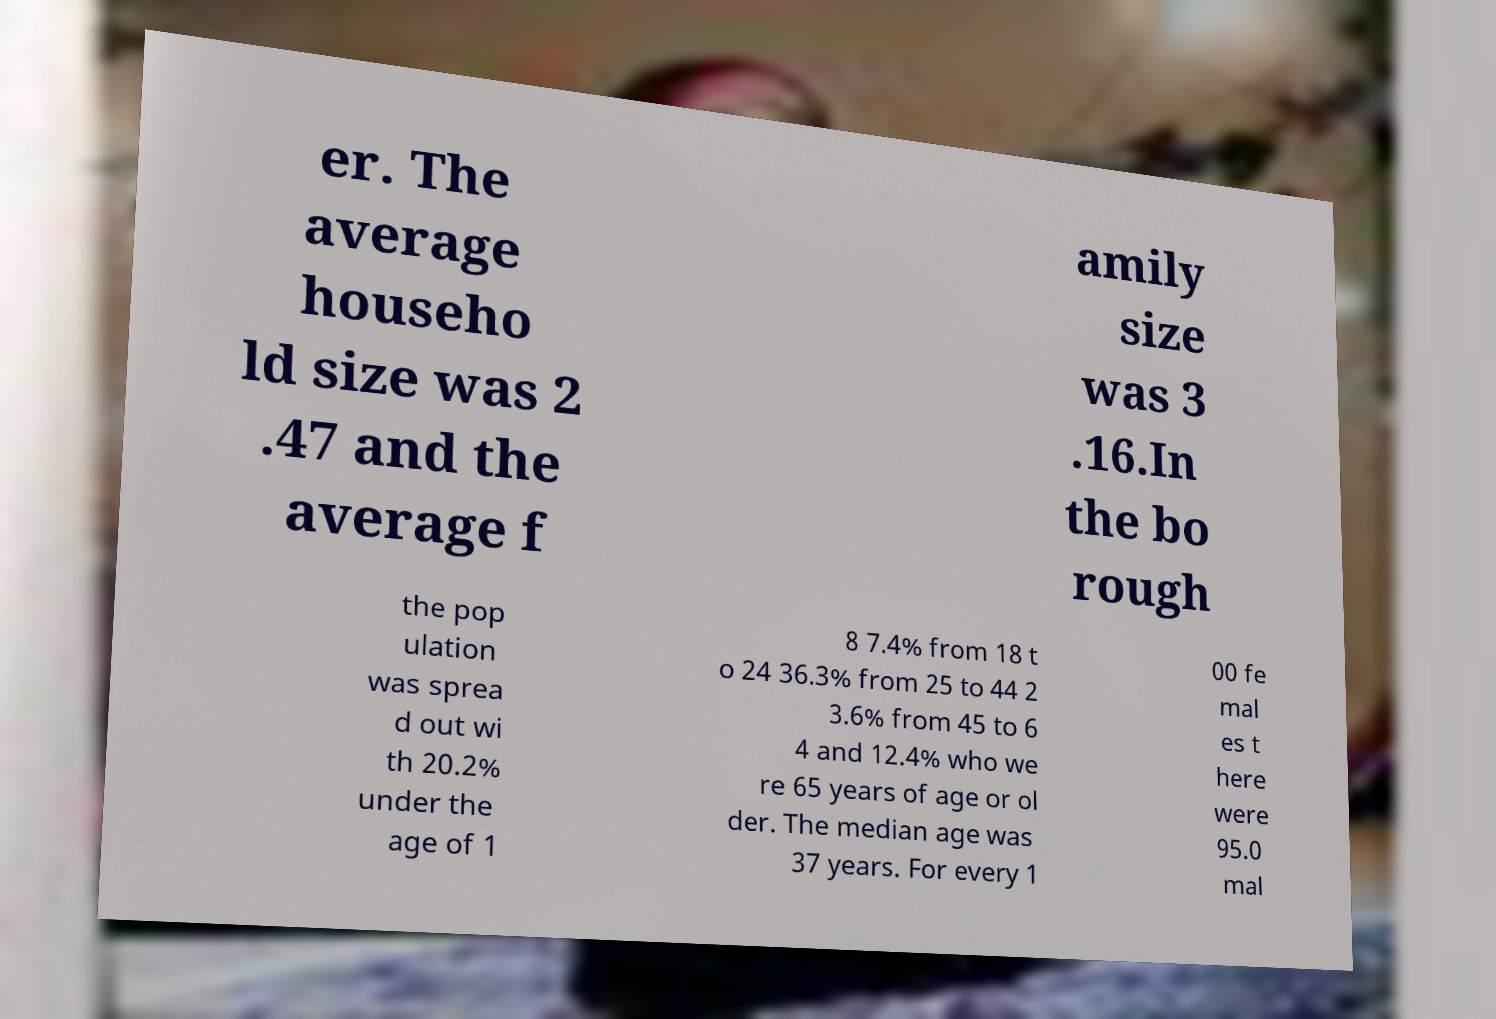For documentation purposes, I need the text within this image transcribed. Could you provide that? er. The average househo ld size was 2 .47 and the average f amily size was 3 .16.In the bo rough the pop ulation was sprea d out wi th 20.2% under the age of 1 8 7.4% from 18 t o 24 36.3% from 25 to 44 2 3.6% from 45 to 6 4 and 12.4% who we re 65 years of age or ol der. The median age was 37 years. For every 1 00 fe mal es t here were 95.0 mal 